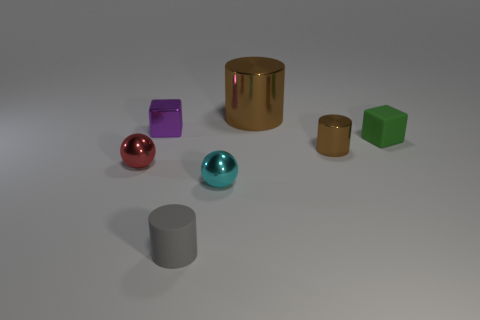Add 2 gray cylinders. How many objects exist? 9 Subtract all blocks. How many objects are left? 5 Add 5 gray rubber things. How many gray rubber things are left? 6 Add 7 purple blocks. How many purple blocks exist? 8 Subtract 1 red spheres. How many objects are left? 6 Subtract all green things. Subtract all metallic spheres. How many objects are left? 4 